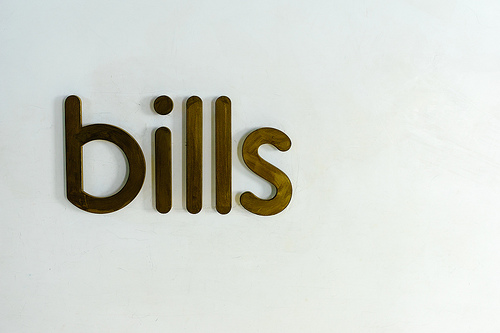<image>
Can you confirm if the letter b is next to the letter s? No. The letter b is not positioned next to the letter s. They are located in different areas of the scene. Is there a letter b in front of the letter s? Yes. The letter b is positioned in front of the letter s, appearing closer to the camera viewpoint. 